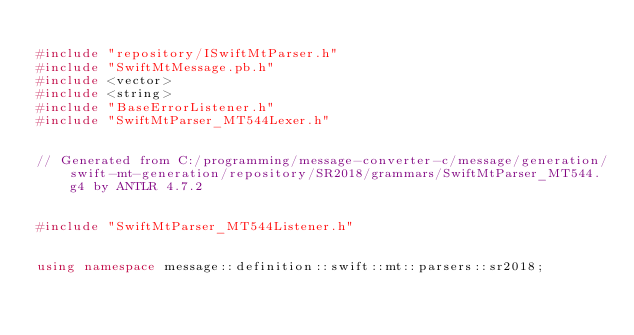Convert code to text. <code><loc_0><loc_0><loc_500><loc_500><_C++_>
#include "repository/ISwiftMtParser.h"
#include "SwiftMtMessage.pb.h"
#include <vector>
#include <string>
#include "BaseErrorListener.h"
#include "SwiftMtParser_MT544Lexer.h"


// Generated from C:/programming/message-converter-c/message/generation/swift-mt-generation/repository/SR2018/grammars/SwiftMtParser_MT544.g4 by ANTLR 4.7.2


#include "SwiftMtParser_MT544Listener.h"


using namespace message::definition::swift::mt::parsers::sr2018;

</code> 